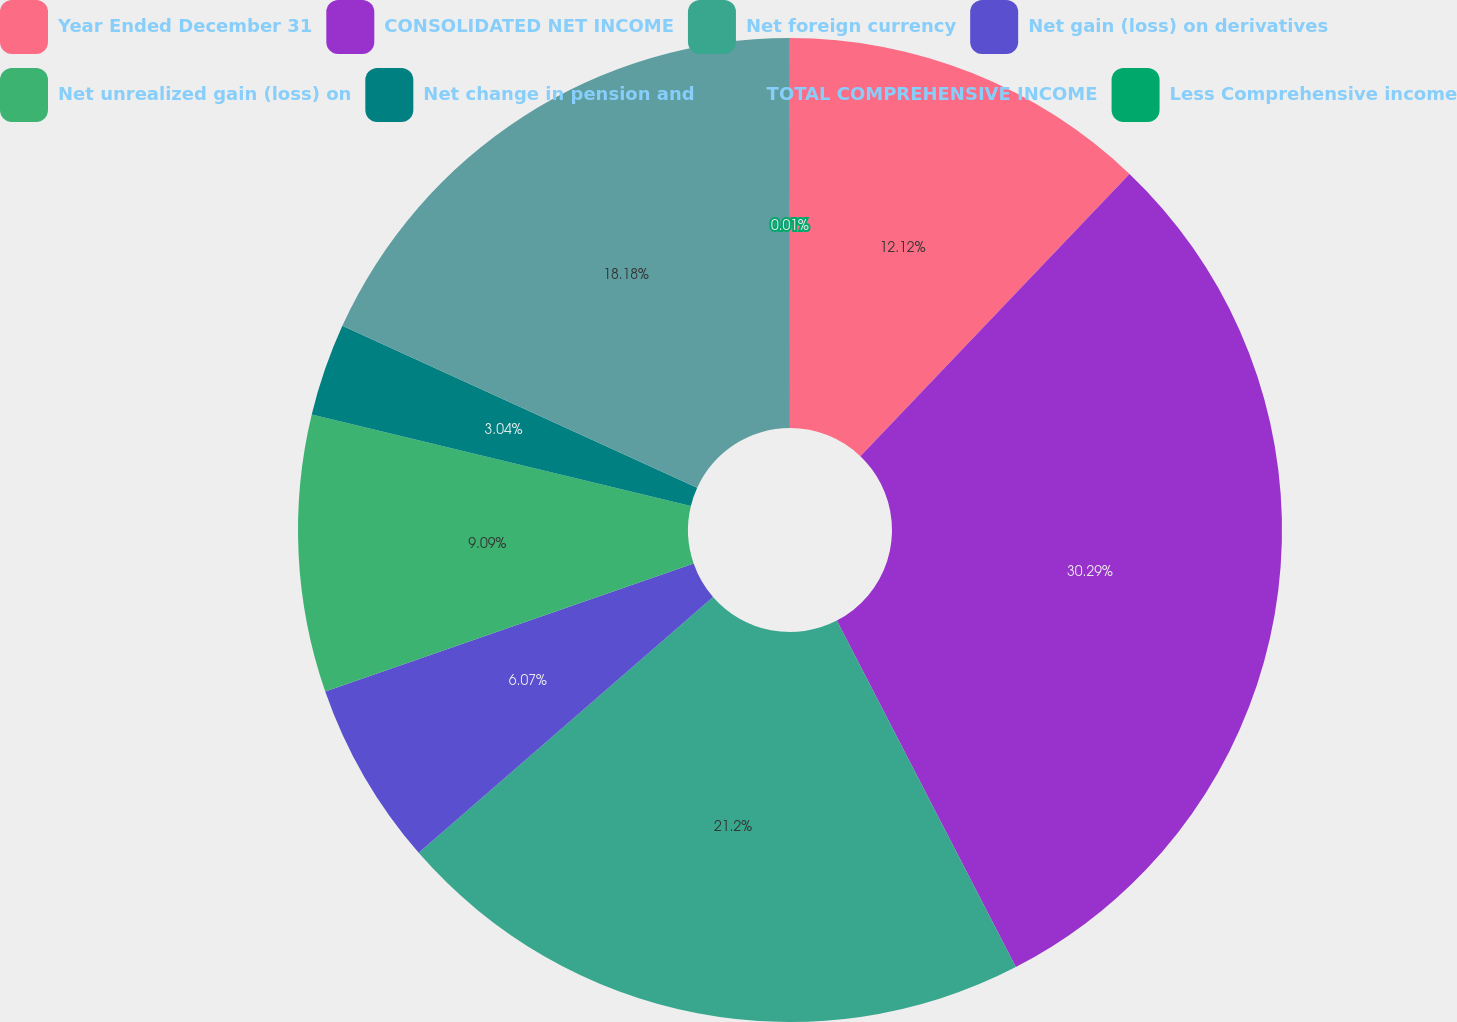<chart> <loc_0><loc_0><loc_500><loc_500><pie_chart><fcel>Year Ended December 31<fcel>CONSOLIDATED NET INCOME<fcel>Net foreign currency<fcel>Net gain (loss) on derivatives<fcel>Net unrealized gain (loss) on<fcel>Net change in pension and<fcel>TOTAL COMPREHENSIVE INCOME<fcel>Less Comprehensive income<nl><fcel>12.12%<fcel>30.29%<fcel>21.2%<fcel>6.07%<fcel>9.09%<fcel>3.04%<fcel>18.18%<fcel>0.01%<nl></chart> 